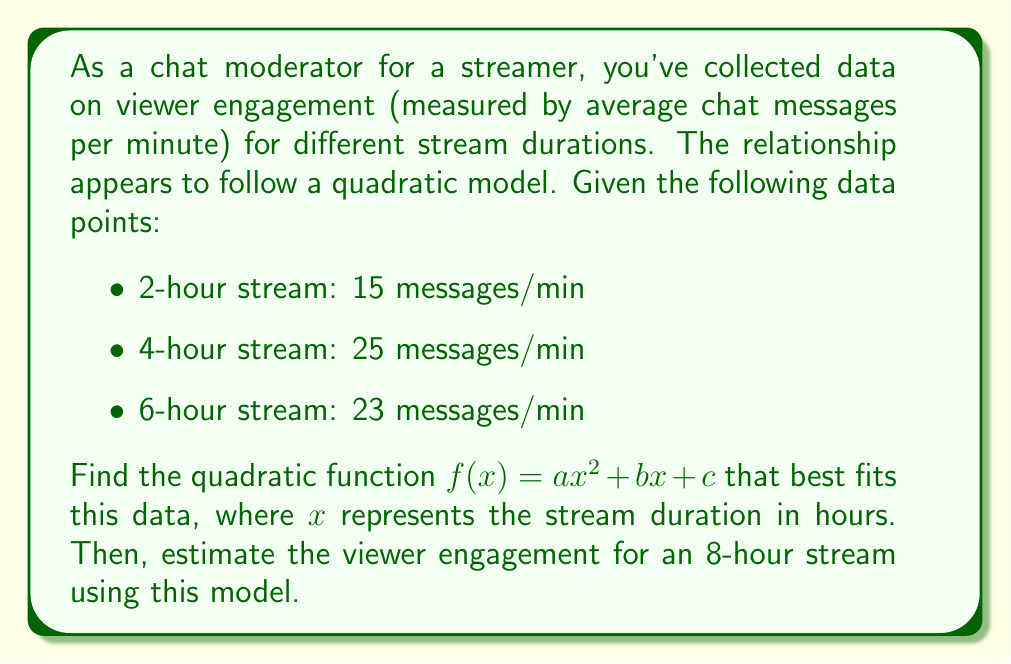Solve this math problem. To solve this problem, we'll follow these steps:

1) Set up a system of equations using the given data points:
   $$a(2)^2 + b(2) + c = 15$$
   $$a(4)^2 + b(4) + c = 25$$
   $$a(6)^2 + b(6) + c = 23$$

2) Simplify:
   $$4a + 2b + c = 15$$ (Equation 1)
   $$16a + 4b + c = 25$$ (Equation 2)
   $$36a + 6b + c = 23$$ (Equation 3)

3) Subtract Equation 1 from Equation 2:
   $$12a + 2b = 10$$ (Equation 4)

4) Subtract Equation 1 from Equation 3:
   $$32a + 4b = 8$$ (Equation 5)

5) Multiply Equation 4 by 2 and subtract from Equation 5:
   $$8a = -12$$
   $$a = -1.5$$

6) Substitute $a = -1.5$ into Equation 4:
   $$-18 + 2b = 10$$
   $$2b = 28$$
   $$b = 14$$

7) Substitute $a = -1.5$ and $b = 14$ into Equation 1:
   $$-6 + 28 + c = 15$$
   $$c = -7$$

8) The quadratic function is:
   $$f(x) = -1.5x^2 + 14x - 7$$

9) To estimate viewer engagement for an 8-hour stream, calculate $f(8)$:
   $$f(8) = -1.5(8)^2 + 14(8) - 7$$
   $$= -1.5(64) + 112 - 7$$
   $$= -96 + 112 - 7$$
   $$= 9$$
Answer: The quadratic function that best fits the data is $f(x) = -1.5x^2 + 14x - 7$, where $x$ is the stream duration in hours. The estimated viewer engagement for an 8-hour stream is 9 messages per minute. 